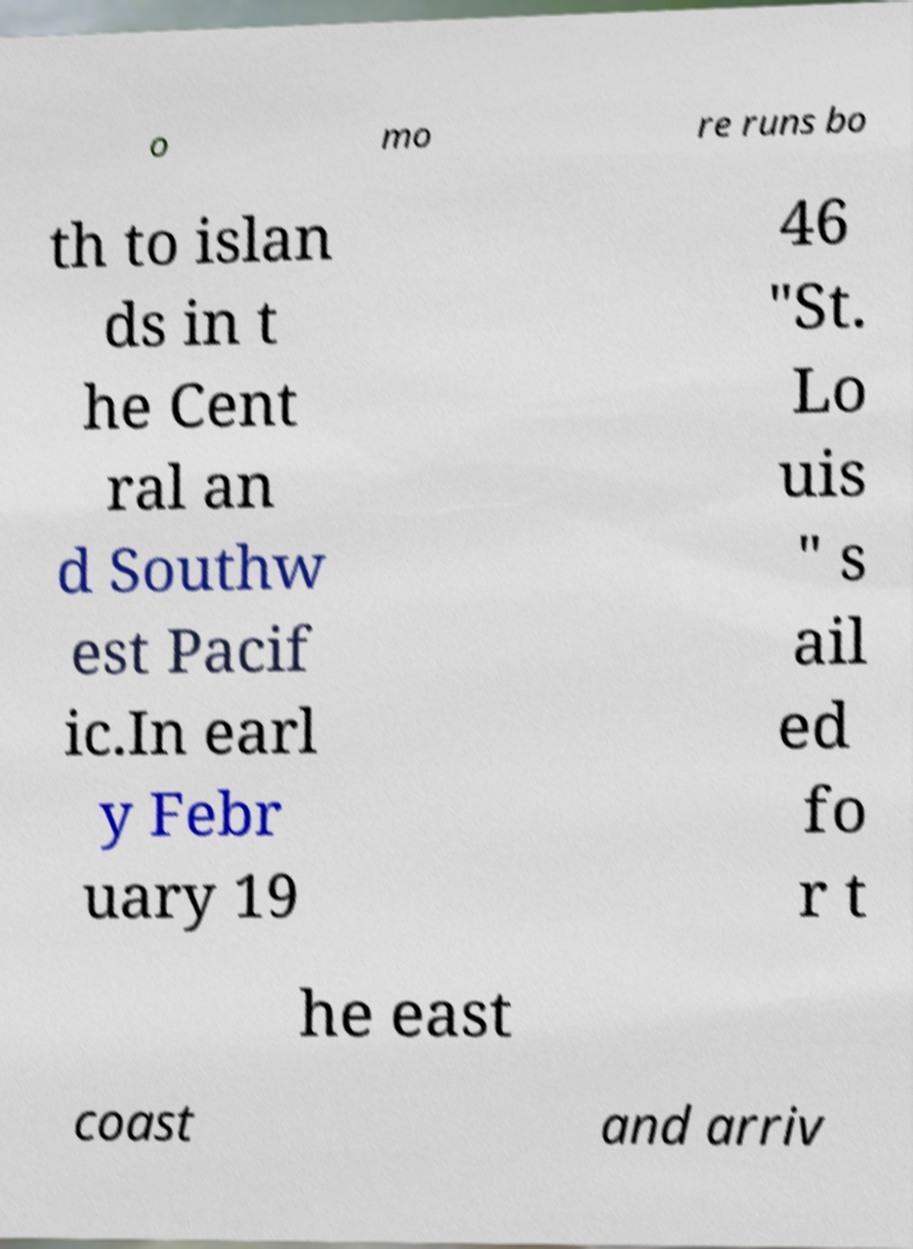I need the written content from this picture converted into text. Can you do that? o mo re runs bo th to islan ds in t he Cent ral an d Southw est Pacif ic.In earl y Febr uary 19 46 "St. Lo uis " s ail ed fo r t he east coast and arriv 